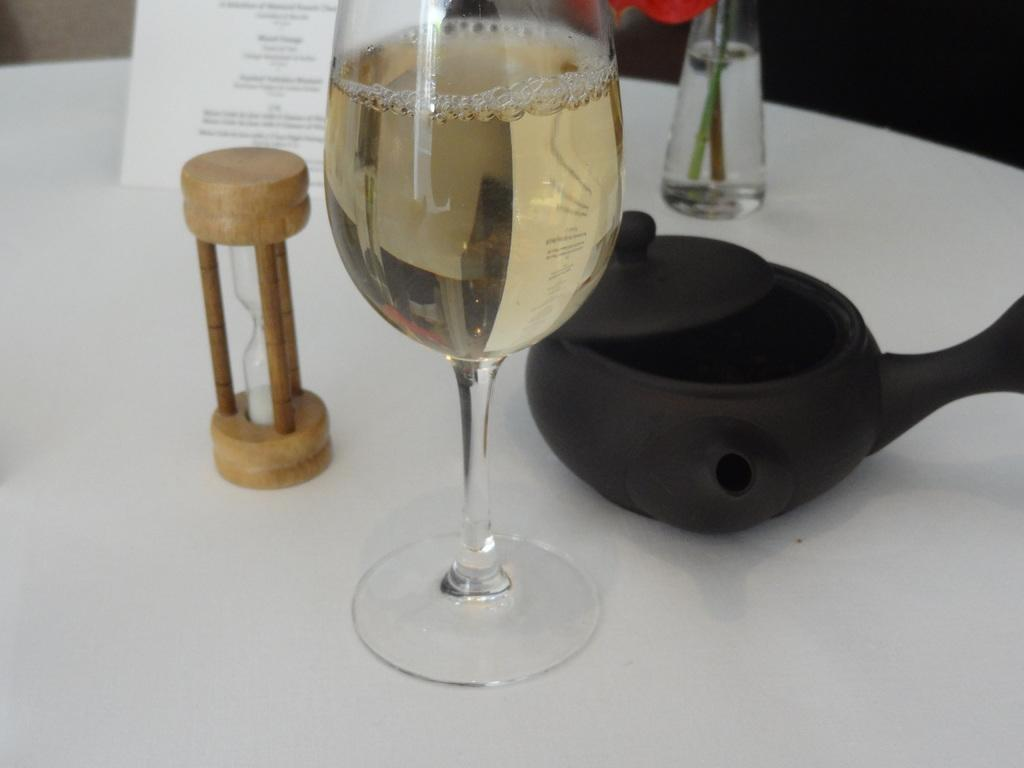What is in the glass that is visible in the image? There is a glass with liquid in the image. What other objects can be seen in the image? There is a tea pot, a flower vase, a card, and a sand timer visible in the image. Where are these objects located in the image? All of these objects are on a table. What type of bat is hanging from the flower vase in the image? There is no bat present in the image; it features a glass with liquid, a tea pot, a flower vase, a card, and a sand timer on a table. What verse can be read from the card in the image? There is no verse visible on the card in the image; it is simply a card among other objects on the table. 